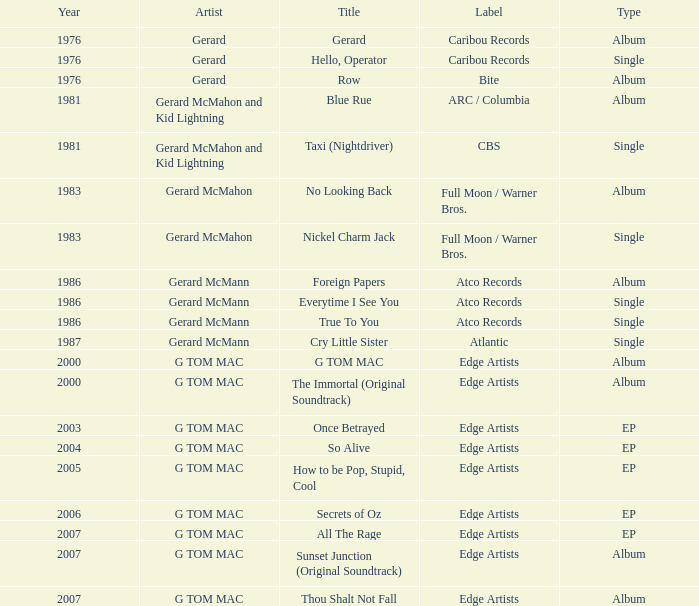Which Title has a Type of album in 1983? No Looking Back. 